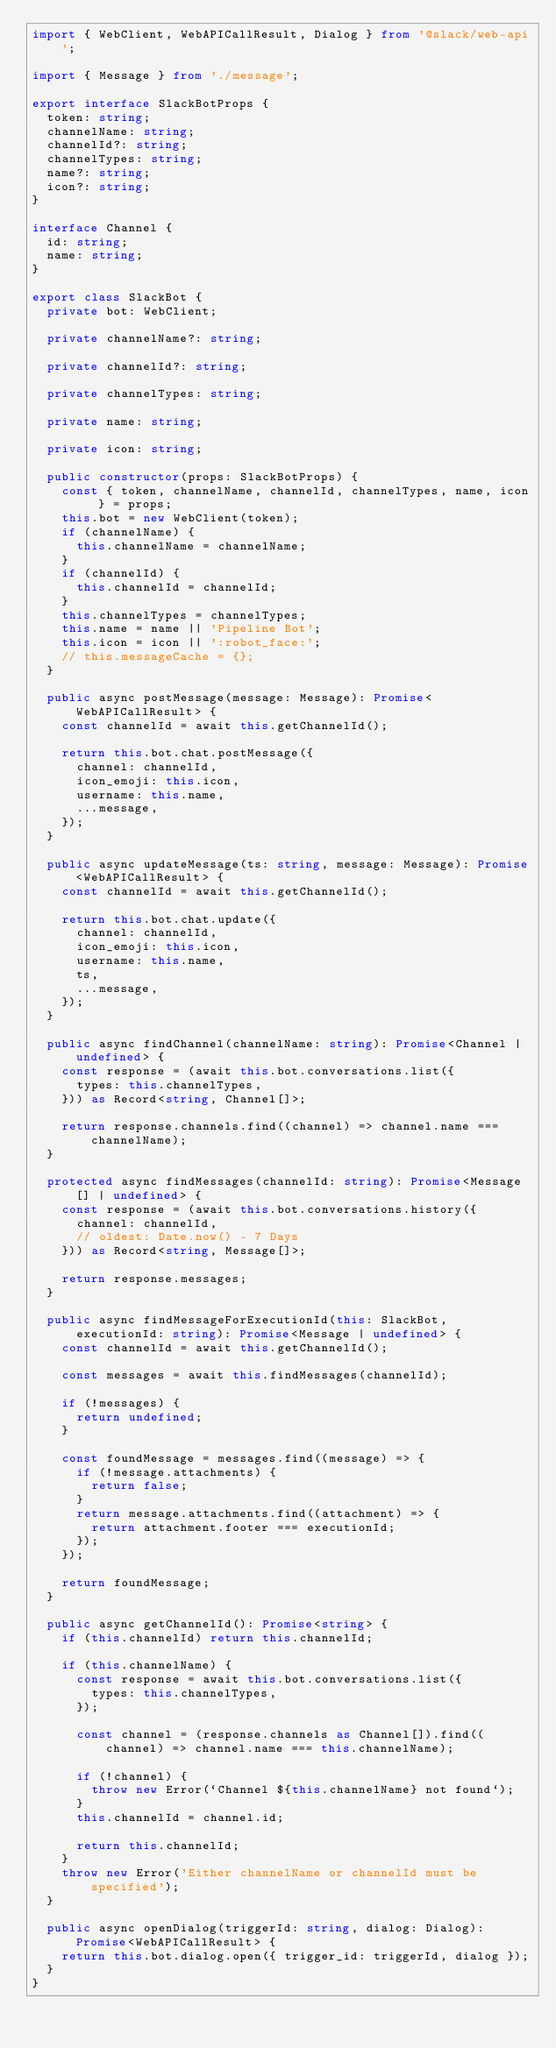<code> <loc_0><loc_0><loc_500><loc_500><_TypeScript_>import { WebClient, WebAPICallResult, Dialog } from '@slack/web-api';

import { Message } from './message';

export interface SlackBotProps {
  token: string;
  channelName: string;
  channelId?: string;
  channelTypes: string;
  name?: string;
  icon?: string;
}

interface Channel {
  id: string;
  name: string;
}

export class SlackBot {
  private bot: WebClient;

  private channelName?: string;

  private channelId?: string;

  private channelTypes: string;

  private name: string;

  private icon: string;

  public constructor(props: SlackBotProps) {
    const { token, channelName, channelId, channelTypes, name, icon } = props;
    this.bot = new WebClient(token);
    if (channelName) {
      this.channelName = channelName;
    }
    if (channelId) {
      this.channelId = channelId;
    }
    this.channelTypes = channelTypes;
    this.name = name || 'Pipeline Bot';
    this.icon = icon || ':robot_face:';
    // this.messageCache = {};
  }

  public async postMessage(message: Message): Promise<WebAPICallResult> {
    const channelId = await this.getChannelId();

    return this.bot.chat.postMessage({
      channel: channelId,
      icon_emoji: this.icon,
      username: this.name,
      ...message,
    });
  }

  public async updateMessage(ts: string, message: Message): Promise<WebAPICallResult> {
    const channelId = await this.getChannelId();

    return this.bot.chat.update({
      channel: channelId,
      icon_emoji: this.icon,
      username: this.name,
      ts,
      ...message,
    });
  }

  public async findChannel(channelName: string): Promise<Channel | undefined> {
    const response = (await this.bot.conversations.list({
      types: this.channelTypes,
    })) as Record<string, Channel[]>;

    return response.channels.find((channel) => channel.name === channelName);
  }

  protected async findMessages(channelId: string): Promise<Message[] | undefined> {
    const response = (await this.bot.conversations.history({
      channel: channelId,
      // oldest: Date.now() - 7 Days
    })) as Record<string, Message[]>;

    return response.messages;
  }

  public async findMessageForExecutionId(this: SlackBot, executionId: string): Promise<Message | undefined> {
    const channelId = await this.getChannelId();

    const messages = await this.findMessages(channelId);

    if (!messages) {
      return undefined;
    }

    const foundMessage = messages.find((message) => {
      if (!message.attachments) {
        return false;
      }
      return message.attachments.find((attachment) => {
        return attachment.footer === executionId;
      });
    });

    return foundMessage;
  }

  public async getChannelId(): Promise<string> {
    if (this.channelId) return this.channelId;

    if (this.channelName) {
      const response = await this.bot.conversations.list({
        types: this.channelTypes,
      });

      const channel = (response.channels as Channel[]).find((channel) => channel.name === this.channelName);

      if (!channel) {
        throw new Error(`Channel ${this.channelName} not found`);
      }
      this.channelId = channel.id;

      return this.channelId;
    }
    throw new Error('Either channelName or channelId must be specified');
  }

  public async openDialog(triggerId: string, dialog: Dialog): Promise<WebAPICallResult> {
    return this.bot.dialog.open({ trigger_id: triggerId, dialog });
  }
}
</code> 